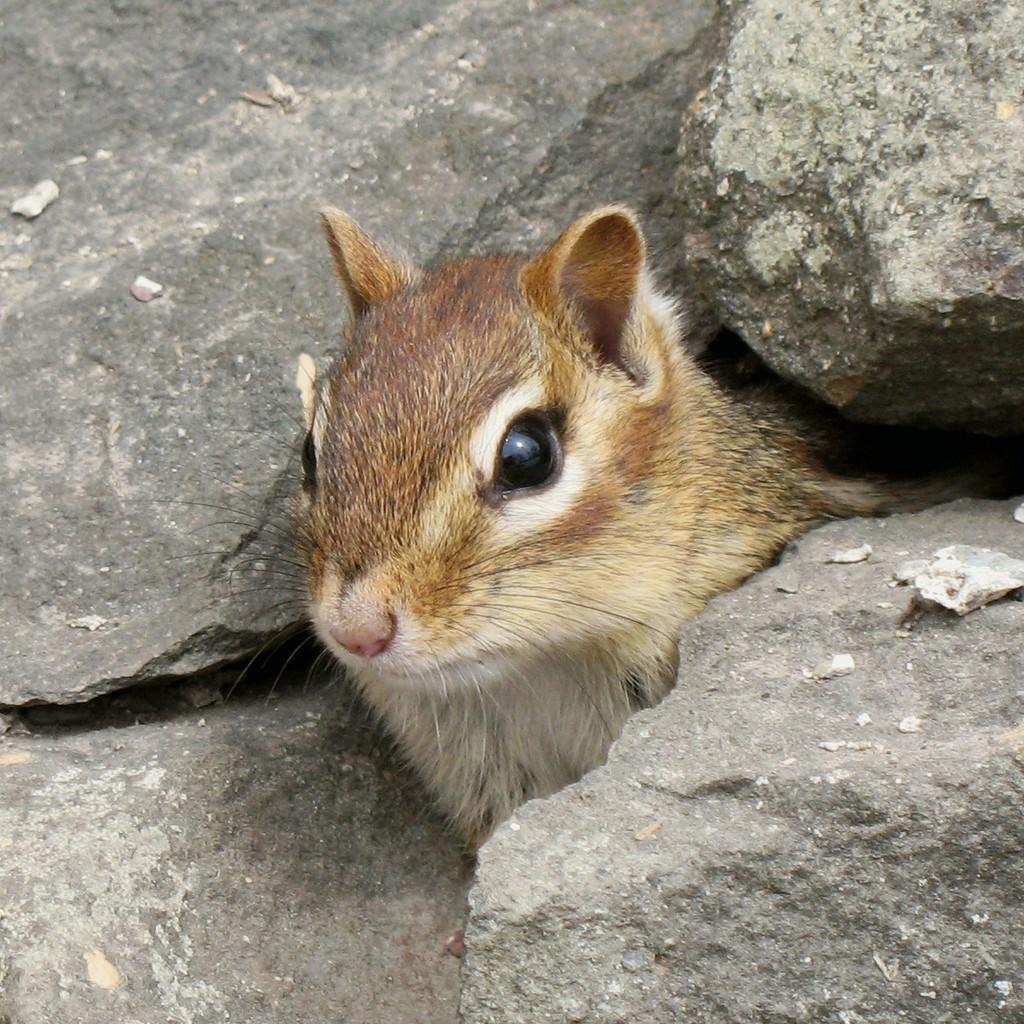How would you summarize this image in a sentence or two? In the center of the image we can see an animal. In the background, we can see some rocks. 